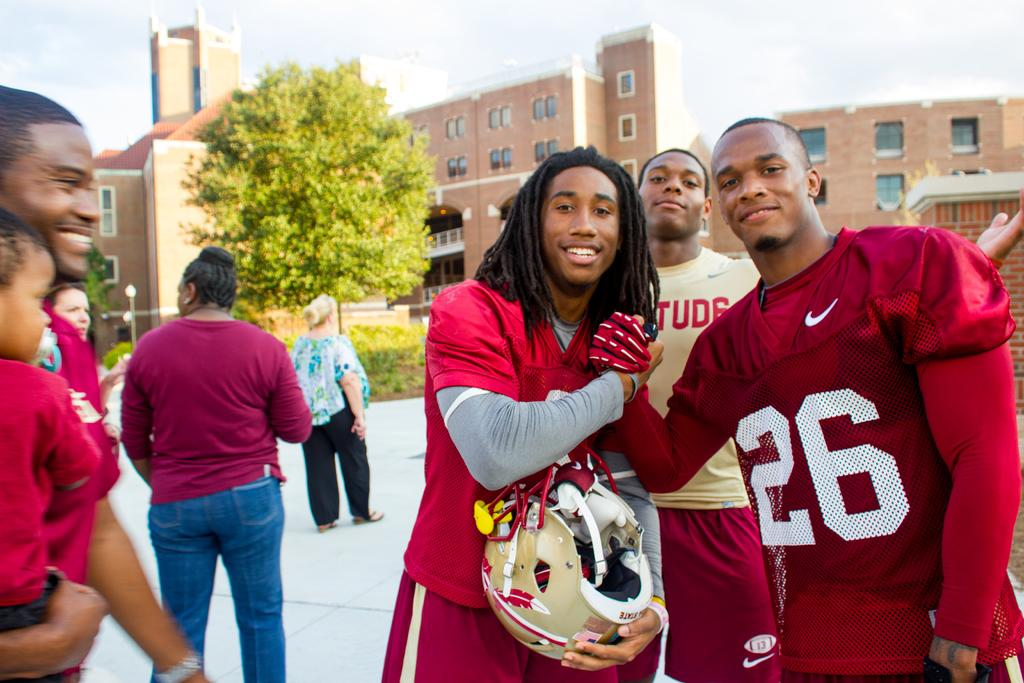<image>
Share a concise interpretation of the image provided. A group of players, one wearing a Studs t-shirt, pose for a picture together. 